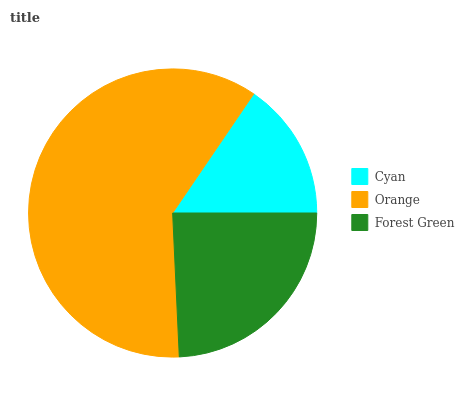Is Cyan the minimum?
Answer yes or no. Yes. Is Orange the maximum?
Answer yes or no. Yes. Is Forest Green the minimum?
Answer yes or no. No. Is Forest Green the maximum?
Answer yes or no. No. Is Orange greater than Forest Green?
Answer yes or no. Yes. Is Forest Green less than Orange?
Answer yes or no. Yes. Is Forest Green greater than Orange?
Answer yes or no. No. Is Orange less than Forest Green?
Answer yes or no. No. Is Forest Green the high median?
Answer yes or no. Yes. Is Forest Green the low median?
Answer yes or no. Yes. Is Cyan the high median?
Answer yes or no. No. Is Cyan the low median?
Answer yes or no. No. 